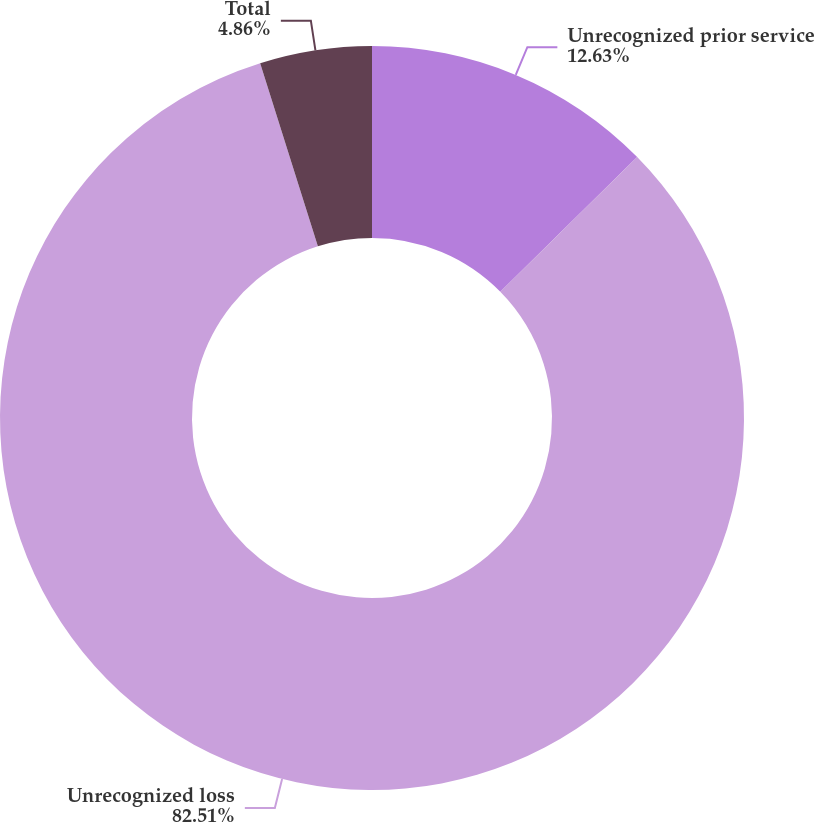Convert chart to OTSL. <chart><loc_0><loc_0><loc_500><loc_500><pie_chart><fcel>Unrecognized prior service<fcel>Unrecognized loss<fcel>Total<nl><fcel>12.63%<fcel>82.51%<fcel>4.86%<nl></chart> 